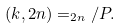Convert formula to latex. <formula><loc_0><loc_0><loc_500><loc_500>( k , 2 n ) = _ { 2 n } / P .</formula> 